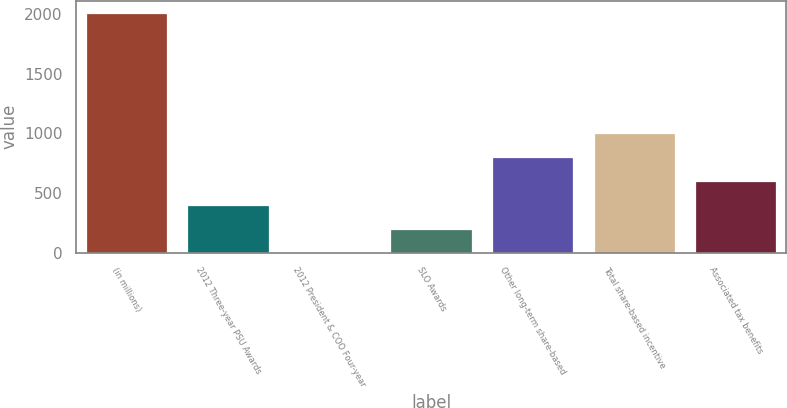<chart> <loc_0><loc_0><loc_500><loc_500><bar_chart><fcel>(in millions)<fcel>2012 Three-year PSU Awards<fcel>2012 President & COO Four-year<fcel>SLO Awards<fcel>Other long-term share-based<fcel>Total share-based incentive<fcel>Associated tax benefits<nl><fcel>2012<fcel>402.56<fcel>0.2<fcel>201.38<fcel>804.92<fcel>1006.1<fcel>603.74<nl></chart> 